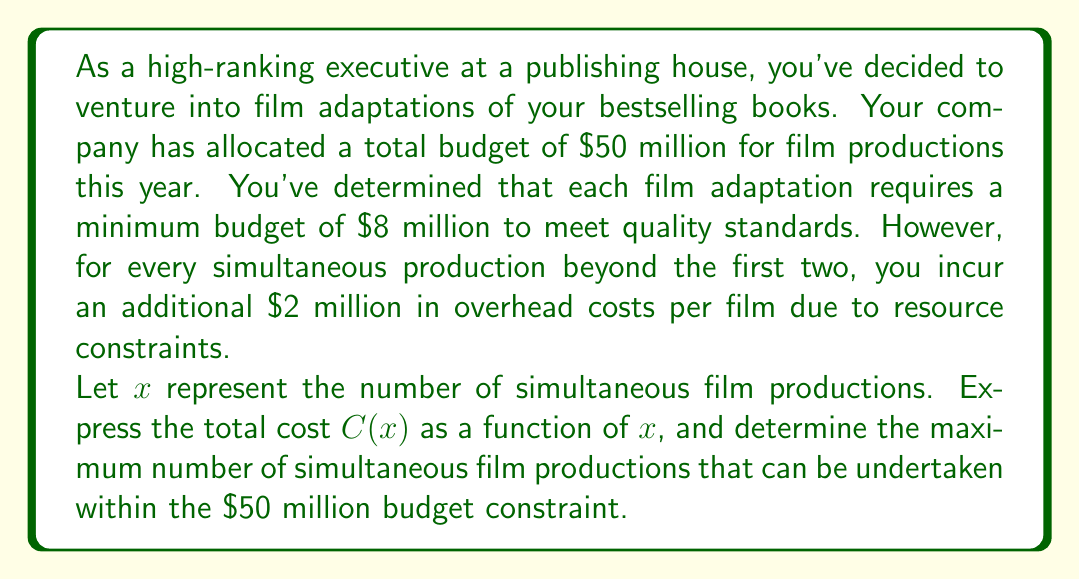What is the answer to this math problem? To solve this problem, we need to follow these steps:

1. Express the total cost $C(x)$ as a function of $x$:
   - For the first two films: $2 \times 8 = 16$ million
   - For each additional film: $8$ million base cost + $2$ million overhead
   - So, for $x > 2$, we add $(x-2)(8+2) = 10(x-2)$ million

   Therefore, the cost function is:
   $$C(x) = \begin{cases}
   8x & \text{if } x \leq 2 \\
   16 + 10(x-2) & \text{if } x > 2
   \end{cases}$$

   This can be simplified to:
   $$C(x) = \begin{cases}
   8x & \text{if } x \leq 2 \\
   10x - 4 & \text{if } x > 2
   \end{cases}$$

2. Set up the inequality for the budget constraint:
   $$C(x) \leq 50$$

3. Solve the inequality for $x > 2$ (since this is the case that will give us the maximum):
   $$10x - 4 \leq 50$$
   $$10x \leq 54$$
   $$x \leq 5.4$$

4. Since $x$ must be a whole number (we can't have a fractional number of film productions), the maximum value for $x$ is 5.

5. Verify that this solution satisfies the original piecewise function:
   $$C(5) = 10(5) - 4 = 50 - 4 = 46 \text{ million}$$
   This is indeed less than or equal to the $50 million budget.
Answer: The maximum number of simultaneous film productions that can be undertaken within the $50 million budget constraint is 5. 